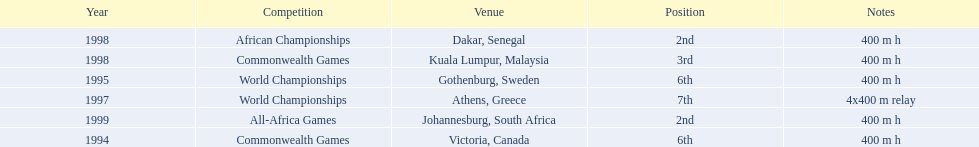What was the venue before dakar, senegal? Kuala Lumpur, Malaysia. 